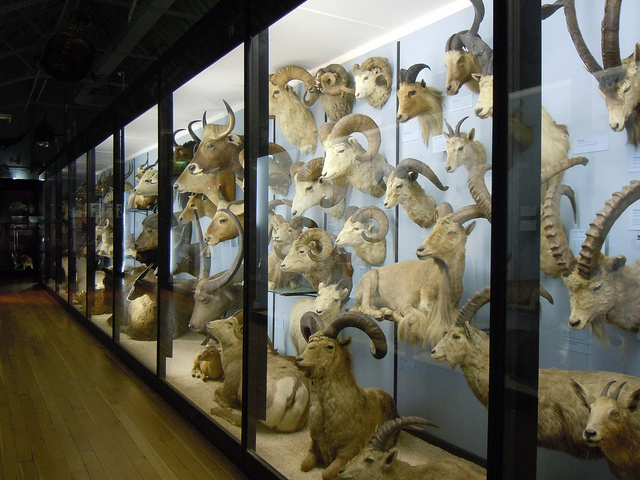Describe the objects in this image and their specific colors. I can see sheep in black, olive, and gray tones, sheep in black, gray, and darkgreen tones, sheep in black, tan, and gray tones, sheep in black, olive, and gray tones, and sheep in black, darkgray, gray, and beige tones in this image. 